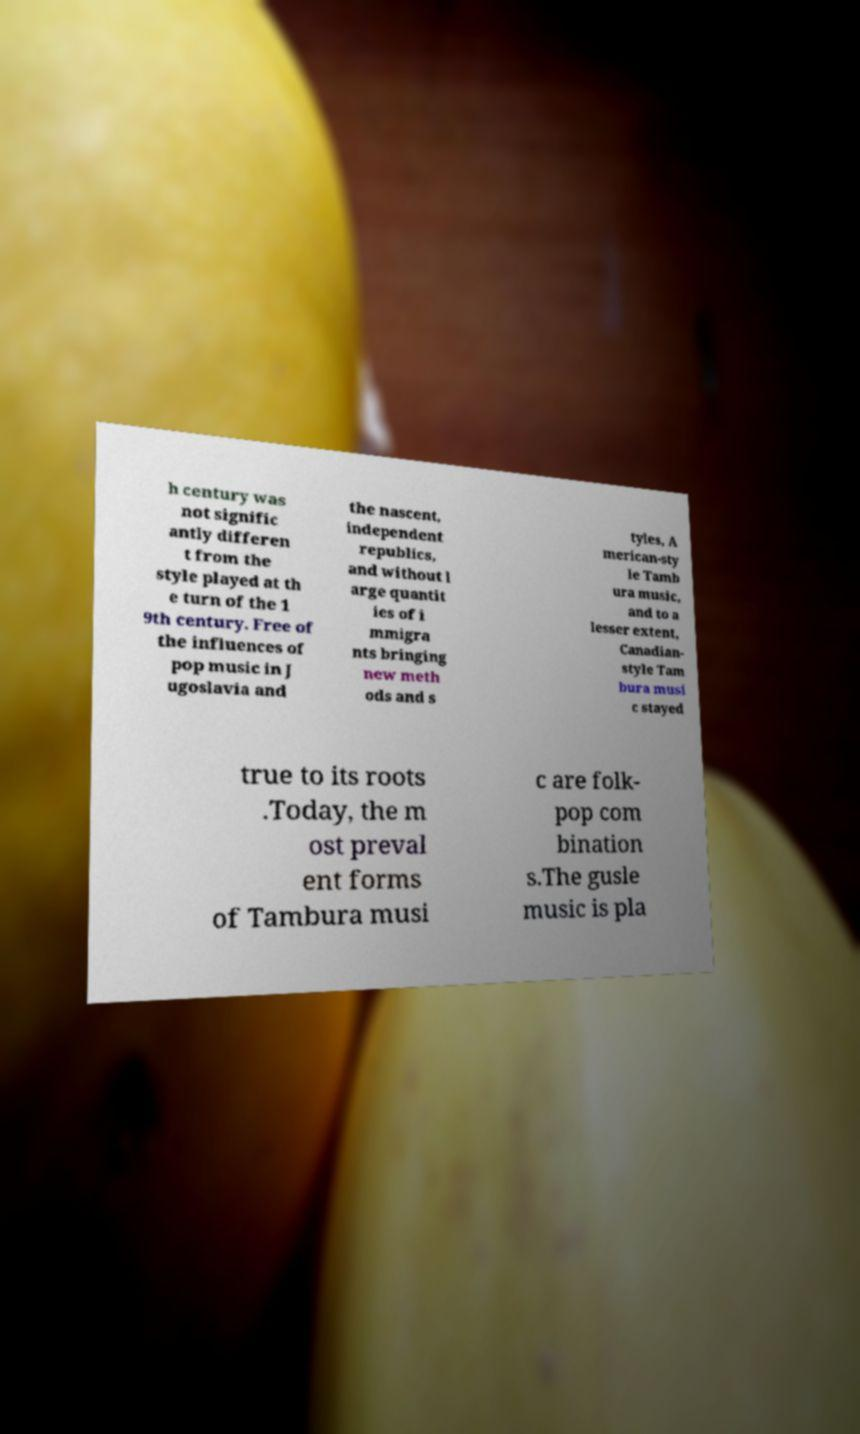Could you extract and type out the text from this image? h century was not signific antly differen t from the style played at th e turn of the 1 9th century. Free of the influences of pop music in J ugoslavia and the nascent, independent republics, and without l arge quantit ies of i mmigra nts bringing new meth ods and s tyles, A merican-sty le Tamb ura music, and to a lesser extent, Canadian- style Tam bura musi c stayed true to its roots .Today, the m ost preval ent forms of Tambura musi c are folk- pop com bination s.The gusle music is pla 